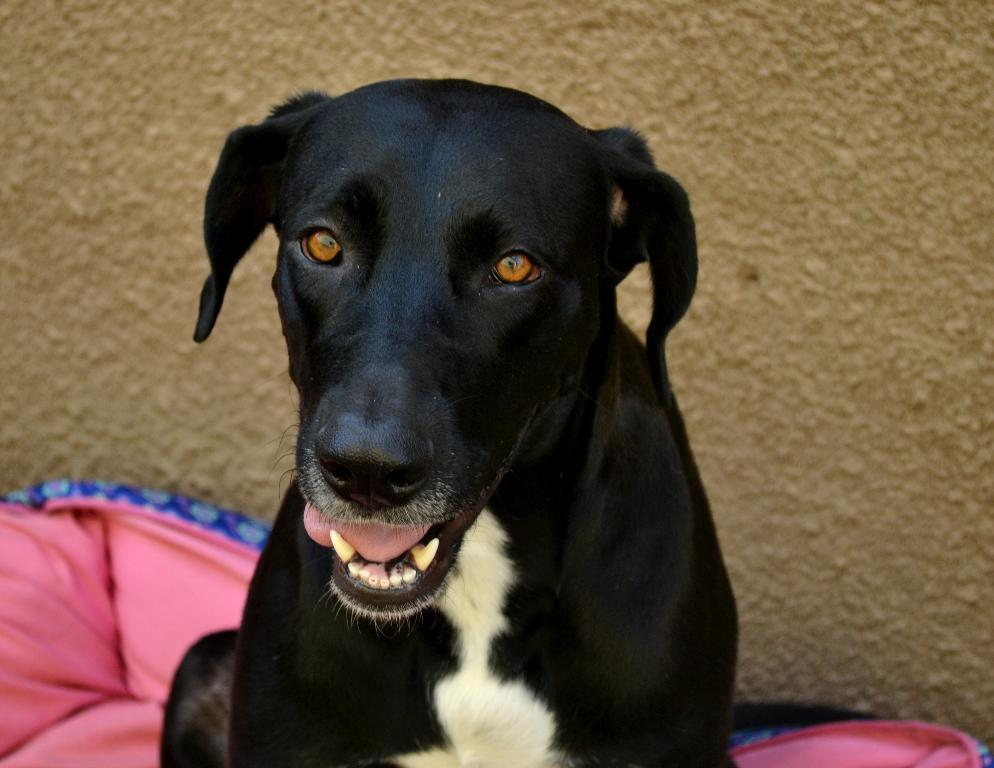What type of animal is present in the image? There is a dog in the image. What color is the object next to the dog? There is a pink object in the image. What can be seen in the distance behind the dog? There is a wall in the background of the image. What type of caption is written on the seashore in the image? There is no caption or seashore present in the image; it features a dog and a pink object with a wall in the background. 